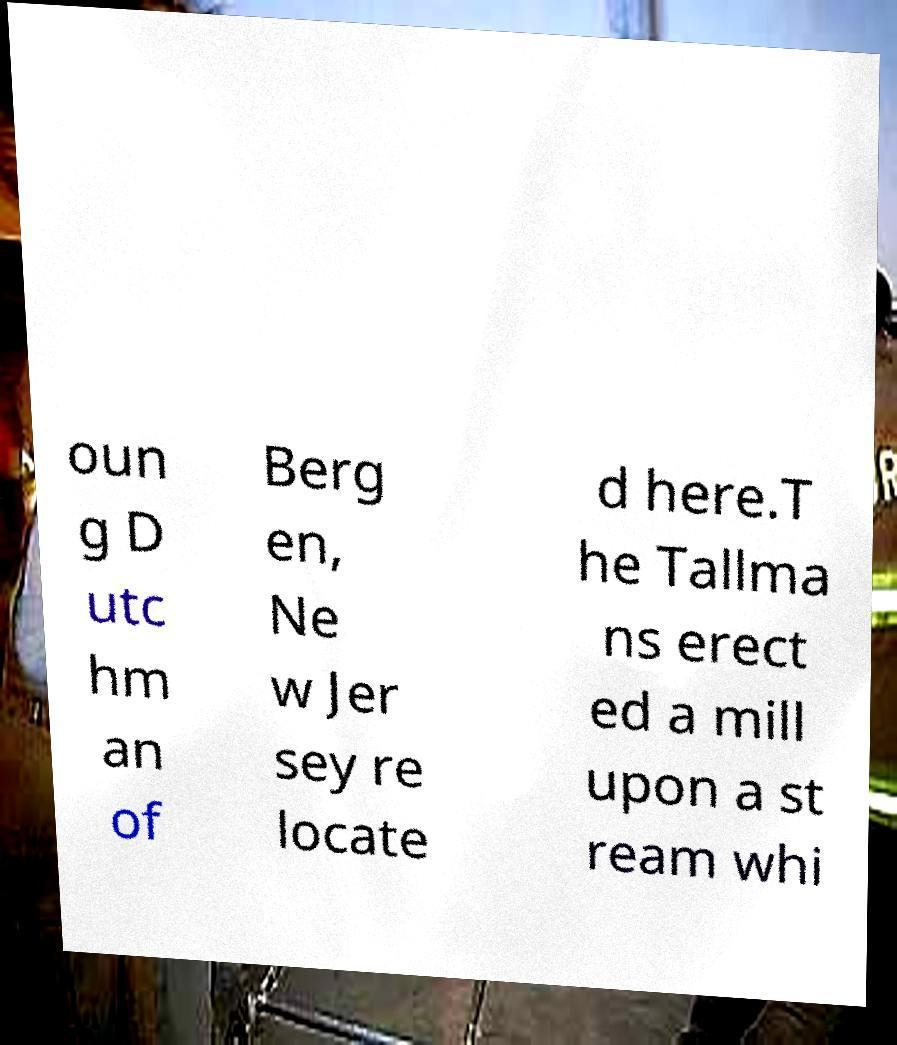For documentation purposes, I need the text within this image transcribed. Could you provide that? oun g D utc hm an of Berg en, Ne w Jer sey re locate d here.T he Tallma ns erect ed a mill upon a st ream whi 